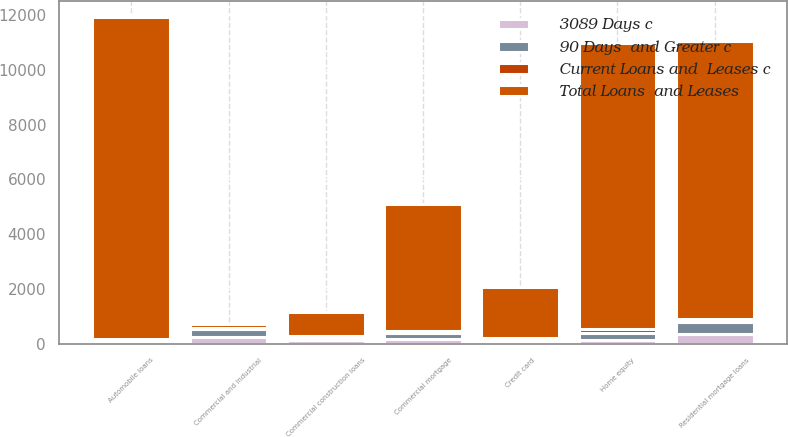Convert chart. <chart><loc_0><loc_0><loc_500><loc_500><stacked_bar_chart><ecel><fcel>Commercial and industrial<fcel>Commercial mortgage<fcel>Commercial construction loans<fcel>Residential mortgage loans<fcel>Home equity<fcel>Automobile loans<fcel>Credit card<nl><fcel>Total Loans  and Leases<fcel>136<fcel>4649<fcel>887<fcel>10149<fcel>10455<fcel>11744<fcel>1873<nl><fcel>Current Loans and  Leases c<fcel>49<fcel>41<fcel>12<fcel>110<fcel>136<fcel>71<fcel>33<nl><fcel>3089 Days c<fcel>241<fcel>182<fcel>121<fcel>348<fcel>128<fcel>12<fcel>72<nl><fcel>90 Days  and Greater c<fcel>290<fcel>223<fcel>133<fcel>458<fcel>264<fcel>83<fcel>105<nl></chart> 